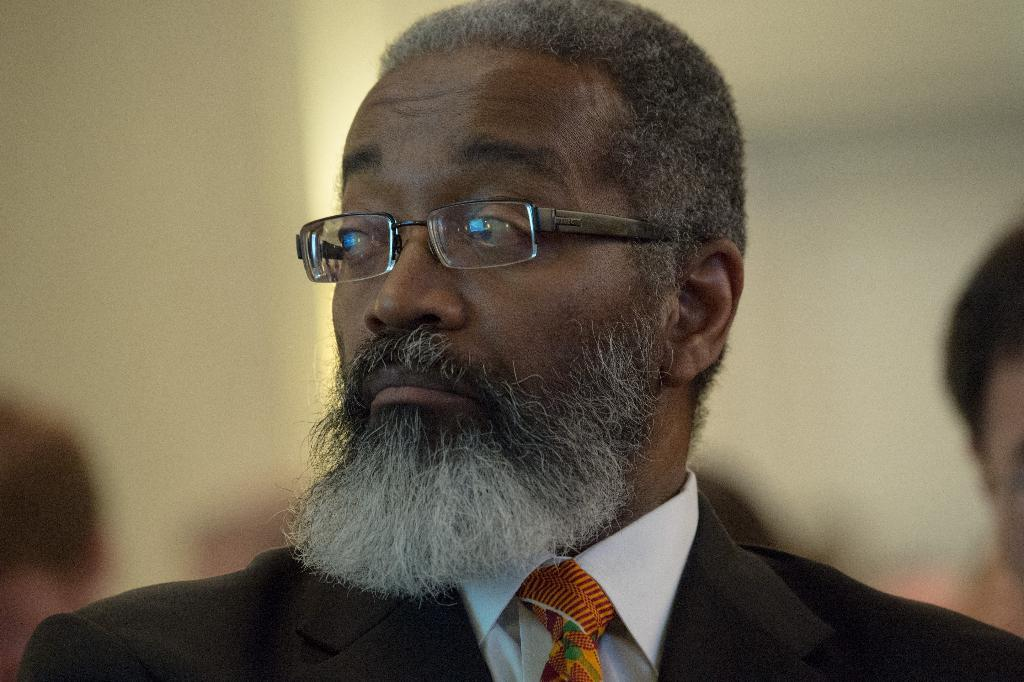Who is present in the image? There is a man in the image. What is the man wearing on his face? The man is wearing glasses (specs) in the image. What type of clothing is the man wearing on his upper body? The man is wearing a black coat in the image. What type of accessory is the man wearing around his neck? The man is wearing a tie in the image. What can be seen in the background of the image? There is sky visible in the background of the image. What type of kite is the man flying in the image? There is no kite present in the image; the man is not flying a kite. 